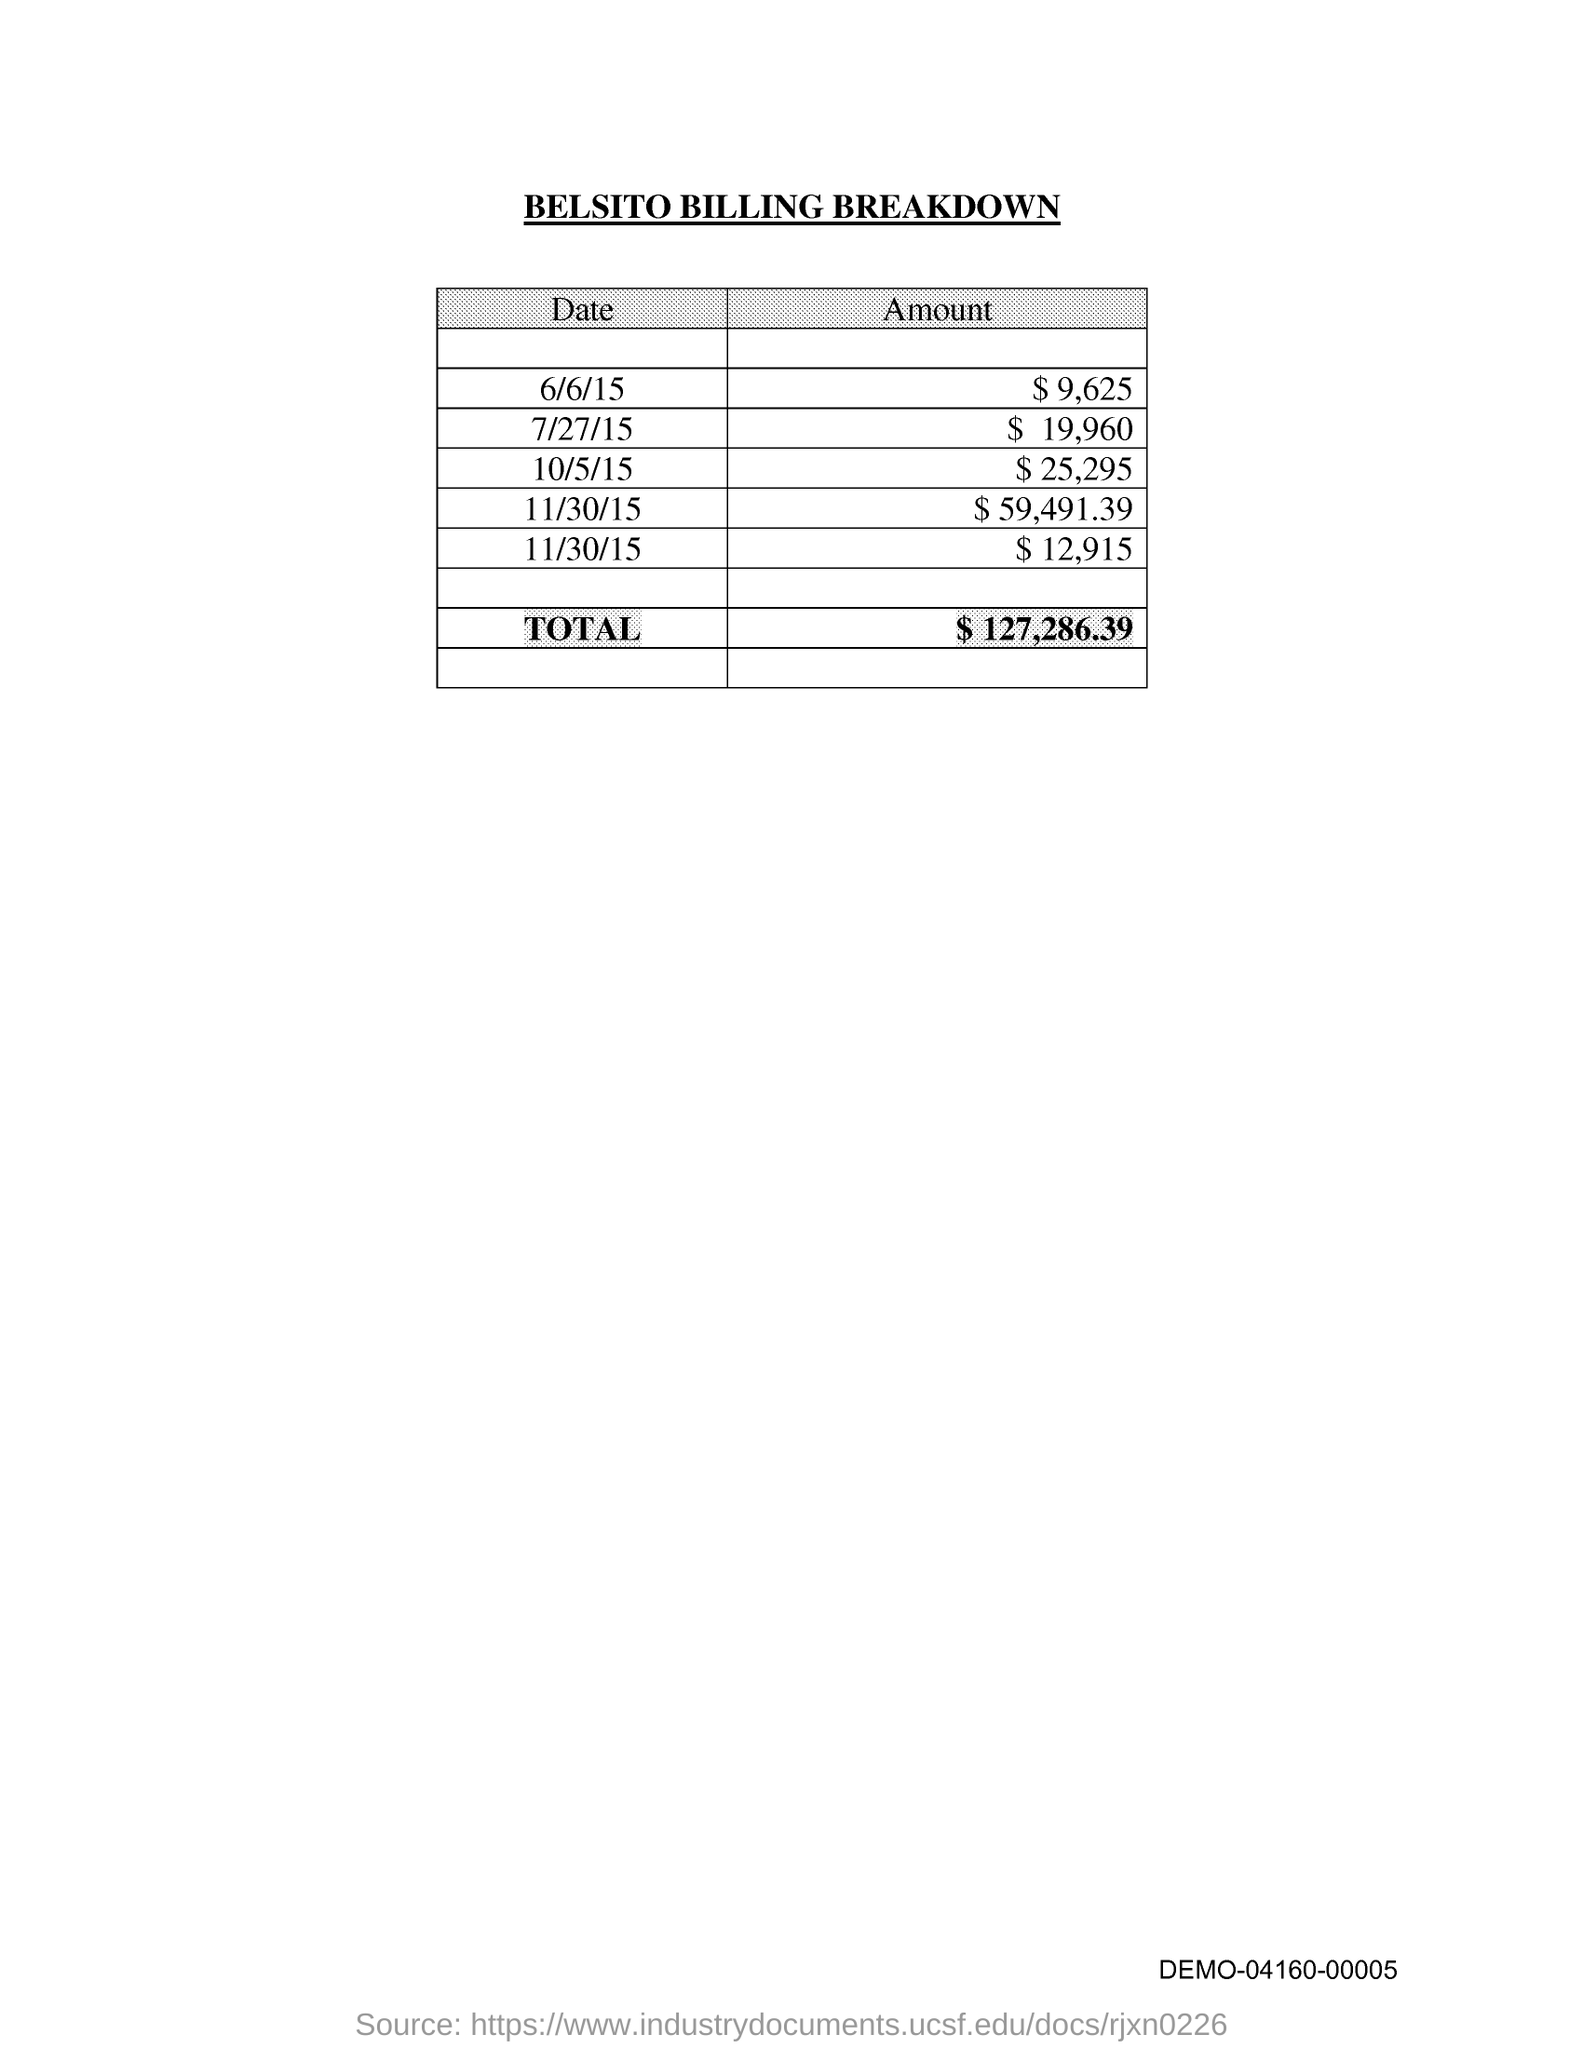What is the Amount for 6/6/15??
Provide a short and direct response. $ 9,625. What is the Amount for 7/27/15??
Ensure brevity in your answer.  $19,960. What is the Amount for 10/5/15??
Offer a terse response. $25,295. What is the Total amount?
Provide a succinct answer. $ 127,286.39. What is the Title of the document?
Your response must be concise. Belsito Billing Breakdown. 